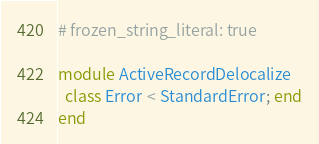<code> <loc_0><loc_0><loc_500><loc_500><_Ruby_># frozen_string_literal: true

module ActiveRecordDelocalize
  class Error < StandardError; end
end
</code> 